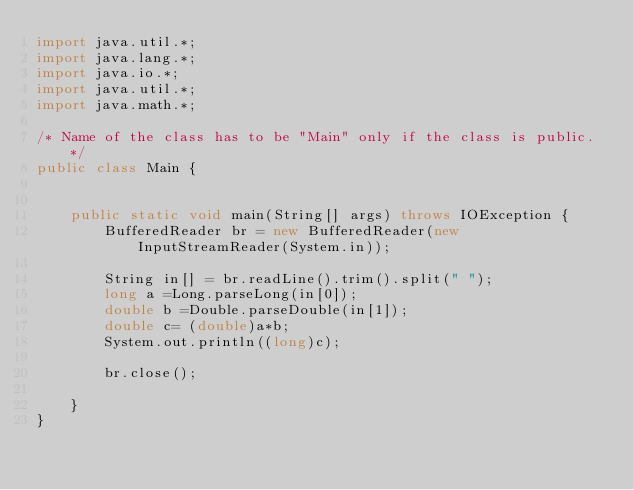Convert code to text. <code><loc_0><loc_0><loc_500><loc_500><_Java_>import java.util.*;
import java.lang.*;
import java.io.*;
import java.util.*;
import java.math.*;

/* Name of the class has to be "Main" only if the class is public. */
public class Main {


    public static void main(String[] args) throws IOException {
        BufferedReader br = new BufferedReader(new InputStreamReader(System.in));

        String in[] = br.readLine().trim().split(" ");
        long a =Long.parseLong(in[0]);
        double b =Double.parseDouble(in[1]);
        double c= (double)a*b;
        System.out.println((long)c);

        br.close();

    }
}</code> 